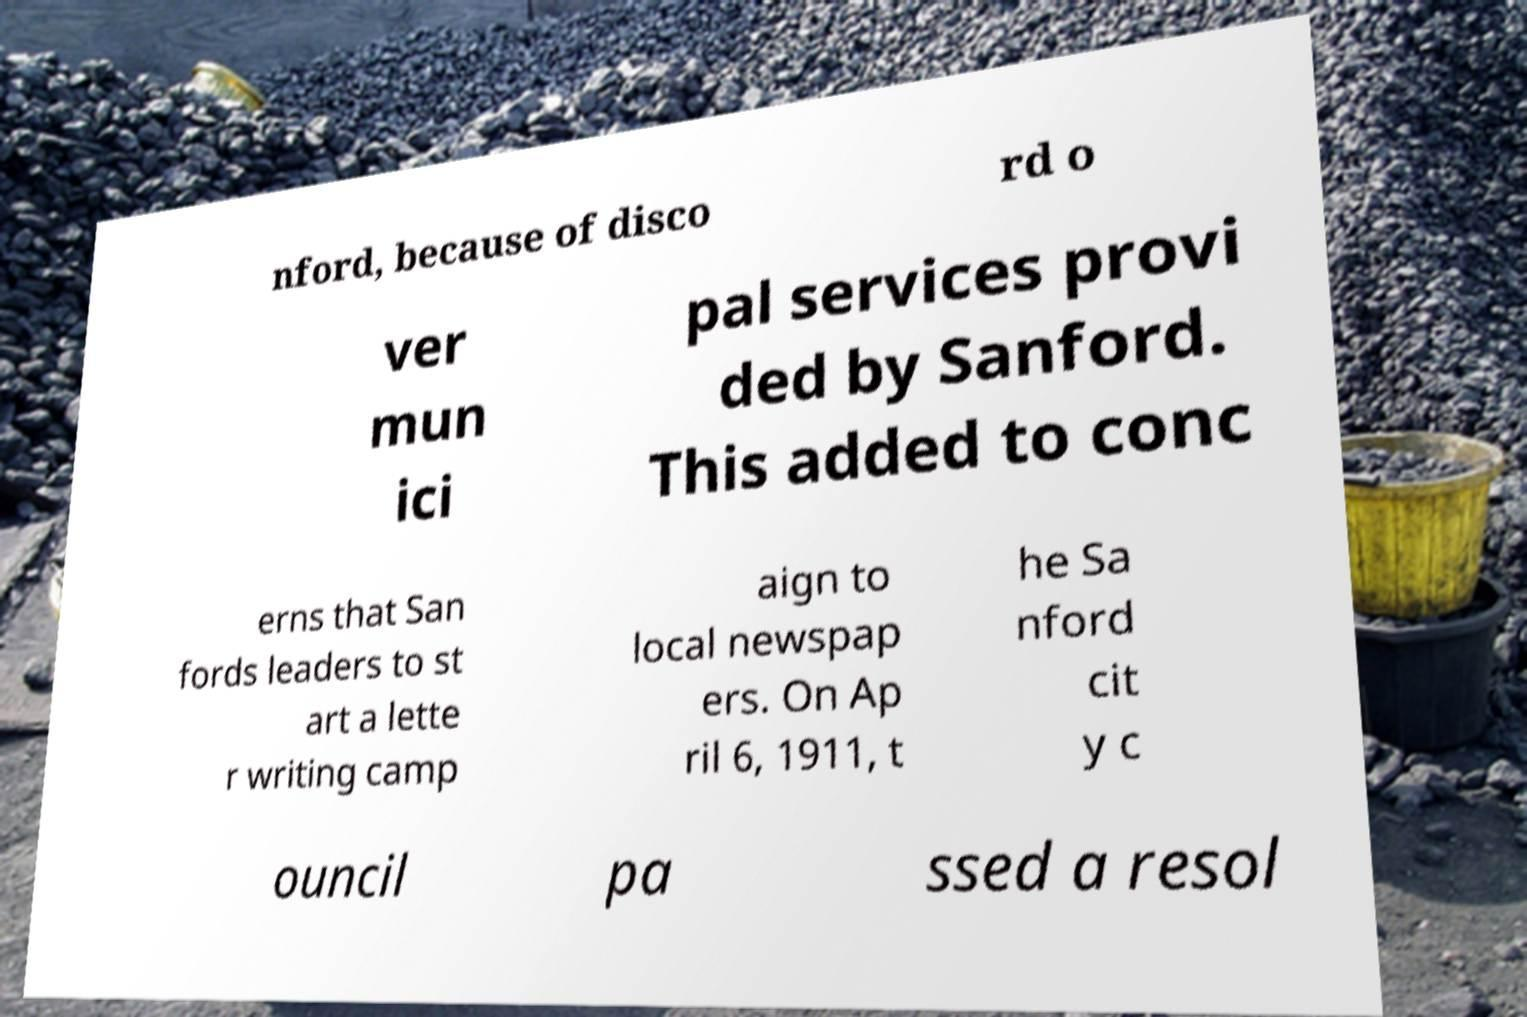Please read and relay the text visible in this image. What does it say? nford, because of disco rd o ver mun ici pal services provi ded by Sanford. This added to conc erns that San fords leaders to st art a lette r writing camp aign to local newspap ers. On Ap ril 6, 1911, t he Sa nford cit y c ouncil pa ssed a resol 